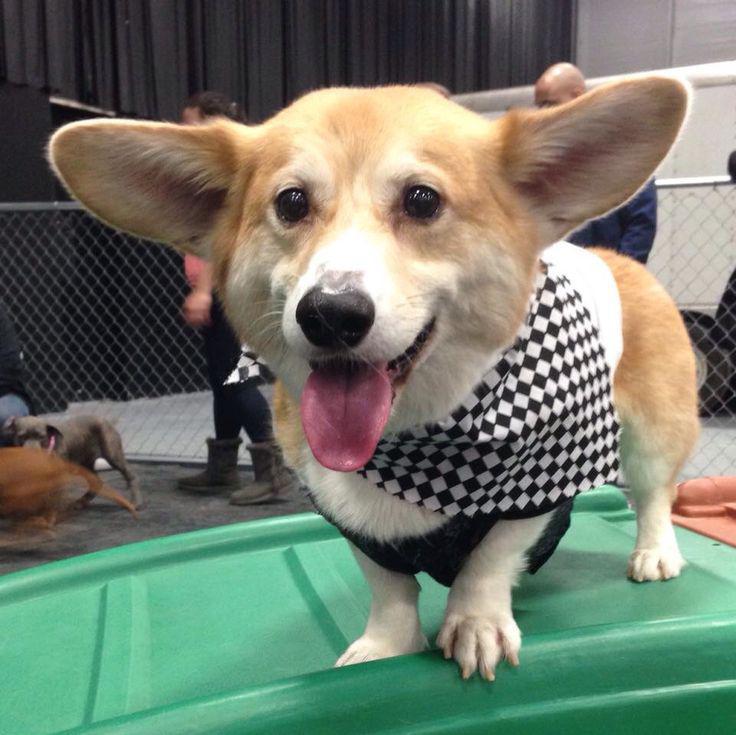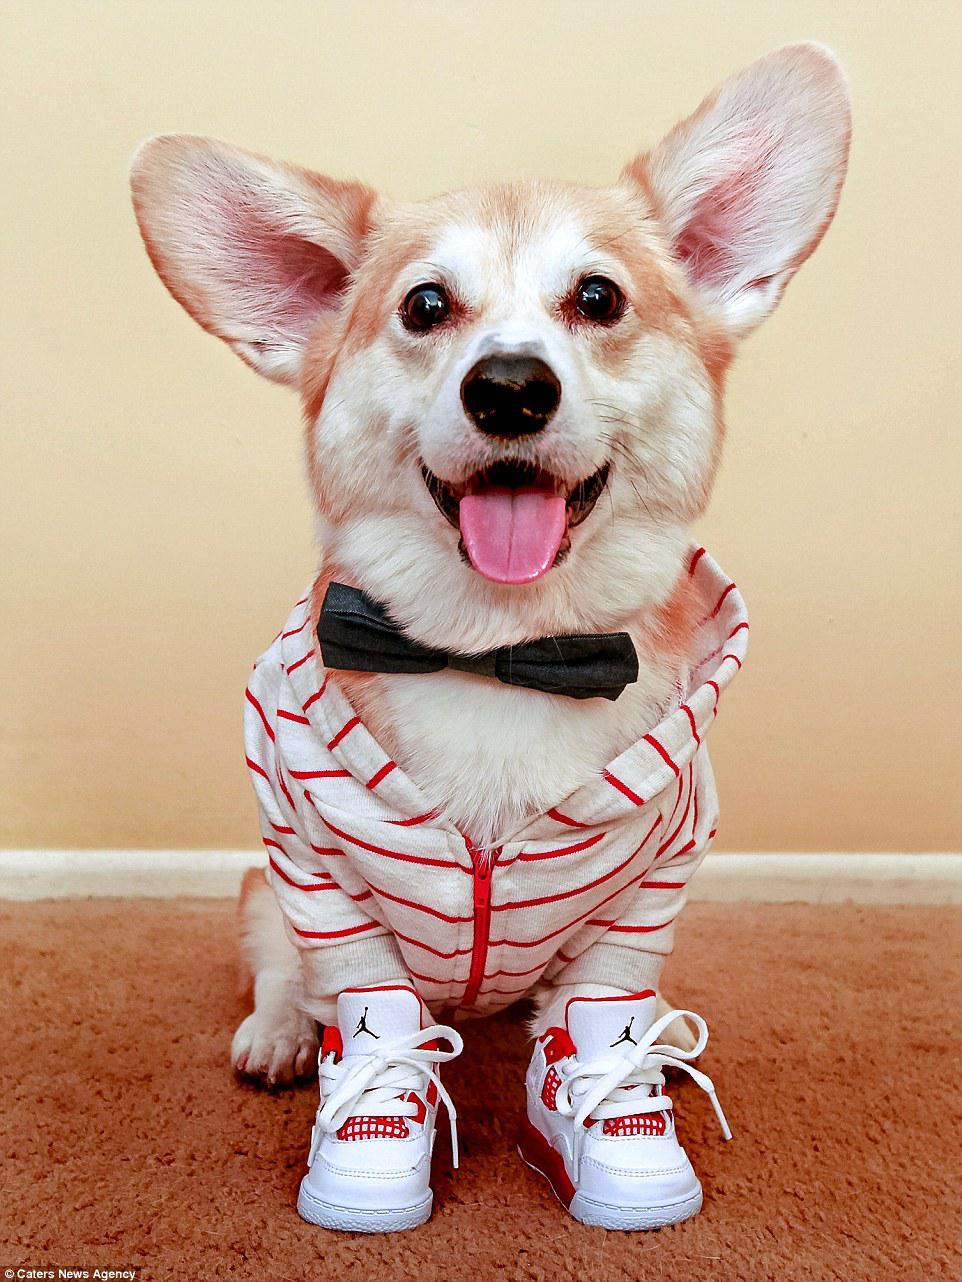The first image is the image on the left, the second image is the image on the right. Considering the images on both sides, is "There is a dog wearing a bow tie and nothing else." valid? Answer yes or no. No. The first image is the image on the left, the second image is the image on the right. Assess this claim about the two images: "The left image features one live dog posed with at least one stuffed animal figure, and the right image shows one dog that is not wearing any human-type attire.". Correct or not? Answer yes or no. No. 